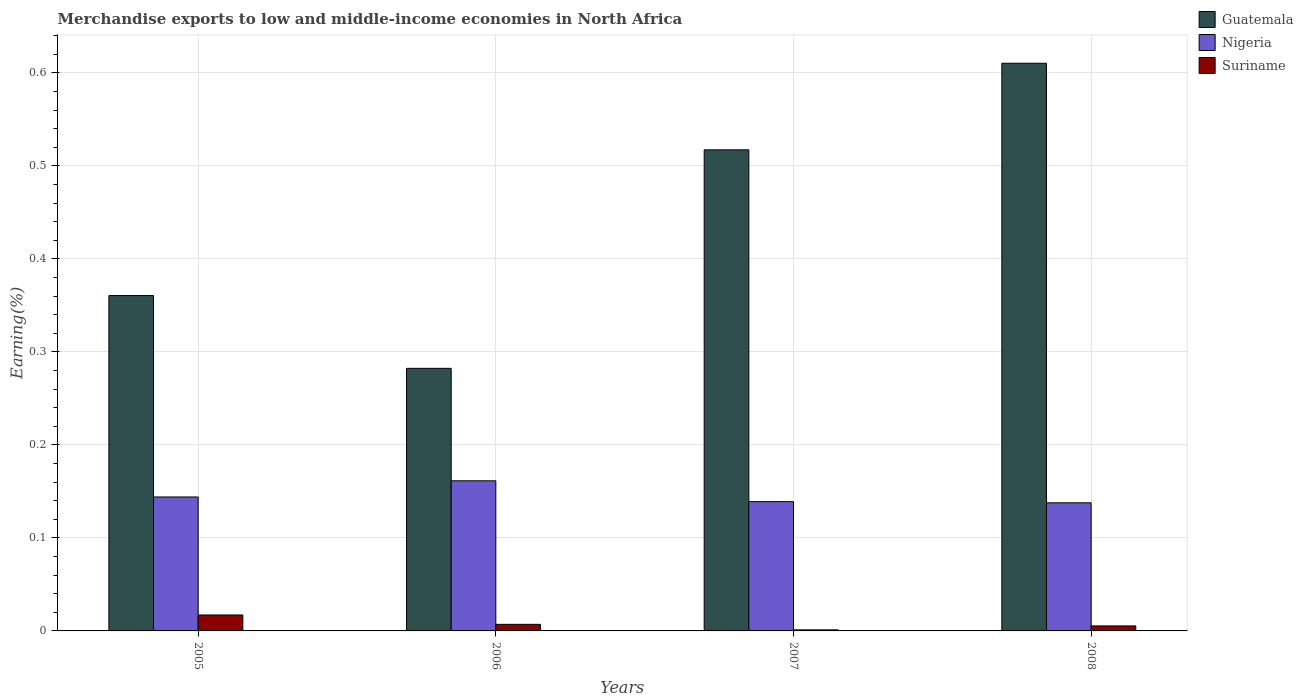How many different coloured bars are there?
Make the answer very short. 3. How many groups of bars are there?
Offer a very short reply. 4. Are the number of bars on each tick of the X-axis equal?
Give a very brief answer. Yes. How many bars are there on the 4th tick from the right?
Offer a terse response. 3. What is the label of the 4th group of bars from the left?
Ensure brevity in your answer.  2008. In how many cases, is the number of bars for a given year not equal to the number of legend labels?
Your response must be concise. 0. What is the percentage of amount earned from merchandise exports in Nigeria in 2007?
Your response must be concise. 0.14. Across all years, what is the maximum percentage of amount earned from merchandise exports in Nigeria?
Your answer should be compact. 0.16. Across all years, what is the minimum percentage of amount earned from merchandise exports in Guatemala?
Provide a succinct answer. 0.28. In which year was the percentage of amount earned from merchandise exports in Nigeria maximum?
Ensure brevity in your answer.  2006. In which year was the percentage of amount earned from merchandise exports in Nigeria minimum?
Offer a terse response. 2008. What is the total percentage of amount earned from merchandise exports in Nigeria in the graph?
Make the answer very short. 0.58. What is the difference between the percentage of amount earned from merchandise exports in Nigeria in 2006 and that in 2008?
Give a very brief answer. 0.02. What is the difference between the percentage of amount earned from merchandise exports in Suriname in 2008 and the percentage of amount earned from merchandise exports in Guatemala in 2007?
Your answer should be very brief. -0.51. What is the average percentage of amount earned from merchandise exports in Suriname per year?
Your answer should be compact. 0.01. In the year 2007, what is the difference between the percentage of amount earned from merchandise exports in Nigeria and percentage of amount earned from merchandise exports in Suriname?
Make the answer very short. 0.14. In how many years, is the percentage of amount earned from merchandise exports in Guatemala greater than 0.1 %?
Your response must be concise. 4. What is the ratio of the percentage of amount earned from merchandise exports in Suriname in 2005 to that in 2006?
Your answer should be compact. 2.43. Is the percentage of amount earned from merchandise exports in Guatemala in 2005 less than that in 2006?
Your answer should be very brief. No. What is the difference between the highest and the second highest percentage of amount earned from merchandise exports in Guatemala?
Provide a short and direct response. 0.09. What is the difference between the highest and the lowest percentage of amount earned from merchandise exports in Guatemala?
Offer a terse response. 0.33. What does the 1st bar from the left in 2008 represents?
Give a very brief answer. Guatemala. What does the 3rd bar from the right in 2008 represents?
Your response must be concise. Guatemala. Are the values on the major ticks of Y-axis written in scientific E-notation?
Ensure brevity in your answer.  No. Does the graph contain any zero values?
Your response must be concise. No. What is the title of the graph?
Give a very brief answer. Merchandise exports to low and middle-income economies in North Africa. What is the label or title of the X-axis?
Ensure brevity in your answer.  Years. What is the label or title of the Y-axis?
Keep it short and to the point. Earning(%). What is the Earning(%) of Guatemala in 2005?
Your answer should be very brief. 0.36. What is the Earning(%) in Nigeria in 2005?
Give a very brief answer. 0.14. What is the Earning(%) in Suriname in 2005?
Keep it short and to the point. 0.02. What is the Earning(%) of Guatemala in 2006?
Offer a terse response. 0.28. What is the Earning(%) in Nigeria in 2006?
Keep it short and to the point. 0.16. What is the Earning(%) in Suriname in 2006?
Offer a terse response. 0.01. What is the Earning(%) of Guatemala in 2007?
Give a very brief answer. 0.52. What is the Earning(%) in Nigeria in 2007?
Provide a succinct answer. 0.14. What is the Earning(%) of Suriname in 2007?
Ensure brevity in your answer.  0. What is the Earning(%) in Guatemala in 2008?
Your answer should be very brief. 0.61. What is the Earning(%) of Nigeria in 2008?
Keep it short and to the point. 0.14. What is the Earning(%) of Suriname in 2008?
Make the answer very short. 0.01. Across all years, what is the maximum Earning(%) in Guatemala?
Ensure brevity in your answer.  0.61. Across all years, what is the maximum Earning(%) of Nigeria?
Ensure brevity in your answer.  0.16. Across all years, what is the maximum Earning(%) of Suriname?
Provide a succinct answer. 0.02. Across all years, what is the minimum Earning(%) in Guatemala?
Ensure brevity in your answer.  0.28. Across all years, what is the minimum Earning(%) in Nigeria?
Give a very brief answer. 0.14. Across all years, what is the minimum Earning(%) in Suriname?
Make the answer very short. 0. What is the total Earning(%) in Guatemala in the graph?
Offer a terse response. 1.77. What is the total Earning(%) of Nigeria in the graph?
Keep it short and to the point. 0.58. What is the total Earning(%) in Suriname in the graph?
Your response must be concise. 0.03. What is the difference between the Earning(%) of Guatemala in 2005 and that in 2006?
Provide a succinct answer. 0.08. What is the difference between the Earning(%) of Nigeria in 2005 and that in 2006?
Provide a short and direct response. -0.02. What is the difference between the Earning(%) of Suriname in 2005 and that in 2006?
Offer a very short reply. 0.01. What is the difference between the Earning(%) of Guatemala in 2005 and that in 2007?
Make the answer very short. -0.16. What is the difference between the Earning(%) of Nigeria in 2005 and that in 2007?
Your answer should be very brief. 0.01. What is the difference between the Earning(%) in Suriname in 2005 and that in 2007?
Keep it short and to the point. 0.02. What is the difference between the Earning(%) of Guatemala in 2005 and that in 2008?
Make the answer very short. -0.25. What is the difference between the Earning(%) of Nigeria in 2005 and that in 2008?
Keep it short and to the point. 0.01. What is the difference between the Earning(%) in Suriname in 2005 and that in 2008?
Offer a very short reply. 0.01. What is the difference between the Earning(%) of Guatemala in 2006 and that in 2007?
Provide a succinct answer. -0.23. What is the difference between the Earning(%) of Nigeria in 2006 and that in 2007?
Your answer should be compact. 0.02. What is the difference between the Earning(%) of Suriname in 2006 and that in 2007?
Your answer should be very brief. 0.01. What is the difference between the Earning(%) in Guatemala in 2006 and that in 2008?
Provide a succinct answer. -0.33. What is the difference between the Earning(%) of Nigeria in 2006 and that in 2008?
Offer a terse response. 0.02. What is the difference between the Earning(%) in Suriname in 2006 and that in 2008?
Your response must be concise. 0. What is the difference between the Earning(%) in Guatemala in 2007 and that in 2008?
Keep it short and to the point. -0.09. What is the difference between the Earning(%) in Nigeria in 2007 and that in 2008?
Make the answer very short. 0. What is the difference between the Earning(%) in Suriname in 2007 and that in 2008?
Make the answer very short. -0. What is the difference between the Earning(%) in Guatemala in 2005 and the Earning(%) in Nigeria in 2006?
Make the answer very short. 0.2. What is the difference between the Earning(%) of Guatemala in 2005 and the Earning(%) of Suriname in 2006?
Give a very brief answer. 0.35. What is the difference between the Earning(%) of Nigeria in 2005 and the Earning(%) of Suriname in 2006?
Provide a short and direct response. 0.14. What is the difference between the Earning(%) of Guatemala in 2005 and the Earning(%) of Nigeria in 2007?
Keep it short and to the point. 0.22. What is the difference between the Earning(%) in Guatemala in 2005 and the Earning(%) in Suriname in 2007?
Your answer should be compact. 0.36. What is the difference between the Earning(%) in Nigeria in 2005 and the Earning(%) in Suriname in 2007?
Your answer should be compact. 0.14. What is the difference between the Earning(%) in Guatemala in 2005 and the Earning(%) in Nigeria in 2008?
Keep it short and to the point. 0.22. What is the difference between the Earning(%) in Guatemala in 2005 and the Earning(%) in Suriname in 2008?
Ensure brevity in your answer.  0.36. What is the difference between the Earning(%) of Nigeria in 2005 and the Earning(%) of Suriname in 2008?
Offer a terse response. 0.14. What is the difference between the Earning(%) in Guatemala in 2006 and the Earning(%) in Nigeria in 2007?
Your answer should be very brief. 0.14. What is the difference between the Earning(%) of Guatemala in 2006 and the Earning(%) of Suriname in 2007?
Provide a short and direct response. 0.28. What is the difference between the Earning(%) in Nigeria in 2006 and the Earning(%) in Suriname in 2007?
Your response must be concise. 0.16. What is the difference between the Earning(%) of Guatemala in 2006 and the Earning(%) of Nigeria in 2008?
Your answer should be compact. 0.14. What is the difference between the Earning(%) of Guatemala in 2006 and the Earning(%) of Suriname in 2008?
Provide a succinct answer. 0.28. What is the difference between the Earning(%) in Nigeria in 2006 and the Earning(%) in Suriname in 2008?
Keep it short and to the point. 0.16. What is the difference between the Earning(%) in Guatemala in 2007 and the Earning(%) in Nigeria in 2008?
Offer a very short reply. 0.38. What is the difference between the Earning(%) of Guatemala in 2007 and the Earning(%) of Suriname in 2008?
Keep it short and to the point. 0.51. What is the difference between the Earning(%) of Nigeria in 2007 and the Earning(%) of Suriname in 2008?
Provide a short and direct response. 0.13. What is the average Earning(%) in Guatemala per year?
Provide a short and direct response. 0.44. What is the average Earning(%) of Nigeria per year?
Keep it short and to the point. 0.15. What is the average Earning(%) of Suriname per year?
Provide a short and direct response. 0.01. In the year 2005, what is the difference between the Earning(%) of Guatemala and Earning(%) of Nigeria?
Keep it short and to the point. 0.22. In the year 2005, what is the difference between the Earning(%) in Guatemala and Earning(%) in Suriname?
Ensure brevity in your answer.  0.34. In the year 2005, what is the difference between the Earning(%) in Nigeria and Earning(%) in Suriname?
Offer a terse response. 0.13. In the year 2006, what is the difference between the Earning(%) of Guatemala and Earning(%) of Nigeria?
Your answer should be very brief. 0.12. In the year 2006, what is the difference between the Earning(%) of Guatemala and Earning(%) of Suriname?
Give a very brief answer. 0.28. In the year 2006, what is the difference between the Earning(%) of Nigeria and Earning(%) of Suriname?
Your response must be concise. 0.15. In the year 2007, what is the difference between the Earning(%) in Guatemala and Earning(%) in Nigeria?
Keep it short and to the point. 0.38. In the year 2007, what is the difference between the Earning(%) of Guatemala and Earning(%) of Suriname?
Provide a short and direct response. 0.52. In the year 2007, what is the difference between the Earning(%) in Nigeria and Earning(%) in Suriname?
Offer a very short reply. 0.14. In the year 2008, what is the difference between the Earning(%) in Guatemala and Earning(%) in Nigeria?
Your answer should be very brief. 0.47. In the year 2008, what is the difference between the Earning(%) of Guatemala and Earning(%) of Suriname?
Provide a succinct answer. 0.61. In the year 2008, what is the difference between the Earning(%) of Nigeria and Earning(%) of Suriname?
Keep it short and to the point. 0.13. What is the ratio of the Earning(%) of Guatemala in 2005 to that in 2006?
Make the answer very short. 1.28. What is the ratio of the Earning(%) of Nigeria in 2005 to that in 2006?
Give a very brief answer. 0.89. What is the ratio of the Earning(%) in Suriname in 2005 to that in 2006?
Your answer should be very brief. 2.43. What is the ratio of the Earning(%) in Guatemala in 2005 to that in 2007?
Make the answer very short. 0.7. What is the ratio of the Earning(%) in Nigeria in 2005 to that in 2007?
Give a very brief answer. 1.04. What is the ratio of the Earning(%) in Suriname in 2005 to that in 2007?
Your answer should be very brief. 15.05. What is the ratio of the Earning(%) of Guatemala in 2005 to that in 2008?
Provide a short and direct response. 0.59. What is the ratio of the Earning(%) in Nigeria in 2005 to that in 2008?
Ensure brevity in your answer.  1.05. What is the ratio of the Earning(%) of Suriname in 2005 to that in 2008?
Provide a short and direct response. 3.19. What is the ratio of the Earning(%) in Guatemala in 2006 to that in 2007?
Provide a short and direct response. 0.55. What is the ratio of the Earning(%) in Nigeria in 2006 to that in 2007?
Offer a very short reply. 1.16. What is the ratio of the Earning(%) in Suriname in 2006 to that in 2007?
Ensure brevity in your answer.  6.2. What is the ratio of the Earning(%) in Guatemala in 2006 to that in 2008?
Your answer should be very brief. 0.46. What is the ratio of the Earning(%) in Nigeria in 2006 to that in 2008?
Your answer should be very brief. 1.17. What is the ratio of the Earning(%) of Suriname in 2006 to that in 2008?
Offer a very short reply. 1.32. What is the ratio of the Earning(%) of Guatemala in 2007 to that in 2008?
Your answer should be very brief. 0.85. What is the ratio of the Earning(%) in Suriname in 2007 to that in 2008?
Keep it short and to the point. 0.21. What is the difference between the highest and the second highest Earning(%) in Guatemala?
Your response must be concise. 0.09. What is the difference between the highest and the second highest Earning(%) in Nigeria?
Provide a short and direct response. 0.02. What is the difference between the highest and the second highest Earning(%) of Suriname?
Your answer should be compact. 0.01. What is the difference between the highest and the lowest Earning(%) of Guatemala?
Keep it short and to the point. 0.33. What is the difference between the highest and the lowest Earning(%) of Nigeria?
Provide a short and direct response. 0.02. What is the difference between the highest and the lowest Earning(%) in Suriname?
Offer a terse response. 0.02. 